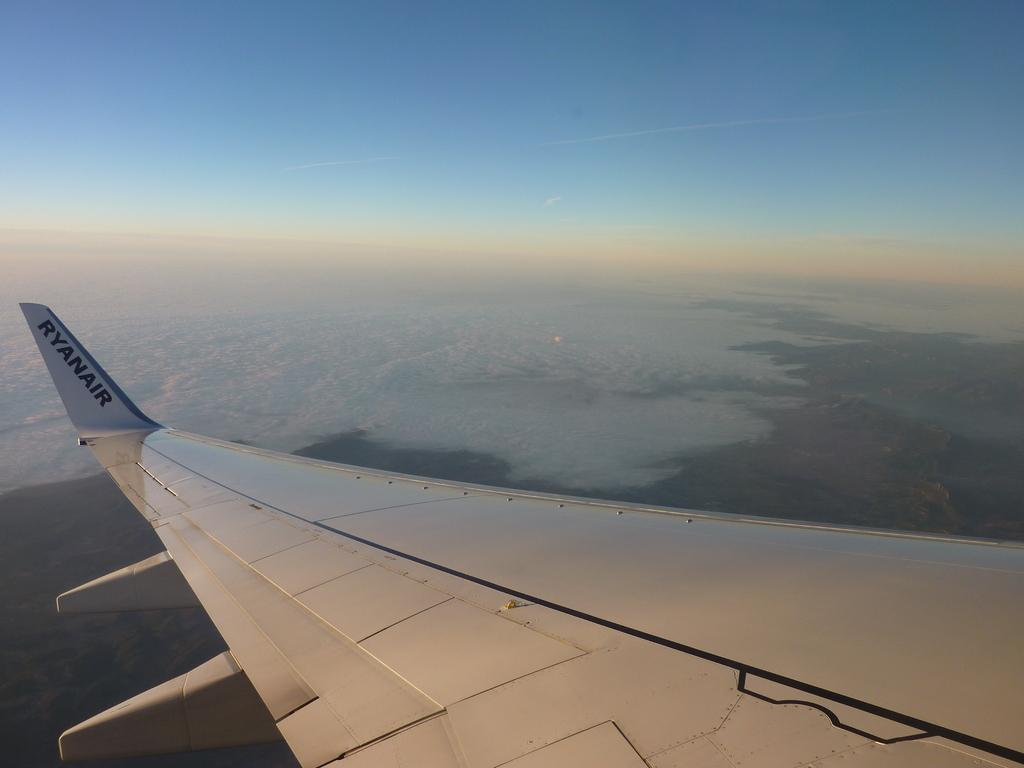What is the main subject of the image? The main subject of the image is an aeroplane wing. What can be seen in the background of the image? There are clouds and the ground visible in the background of the image. What part of the sky is visible in the image? The sky is visible in the background of the image. What type of tin can be seen holding fuel in the image? There is no tin or fuel present in the image; it features an aeroplane wing and clouds in the background. How many bottles are visible in the image? There are no bottles visible in the image. 